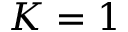<formula> <loc_0><loc_0><loc_500><loc_500>K = 1</formula> 